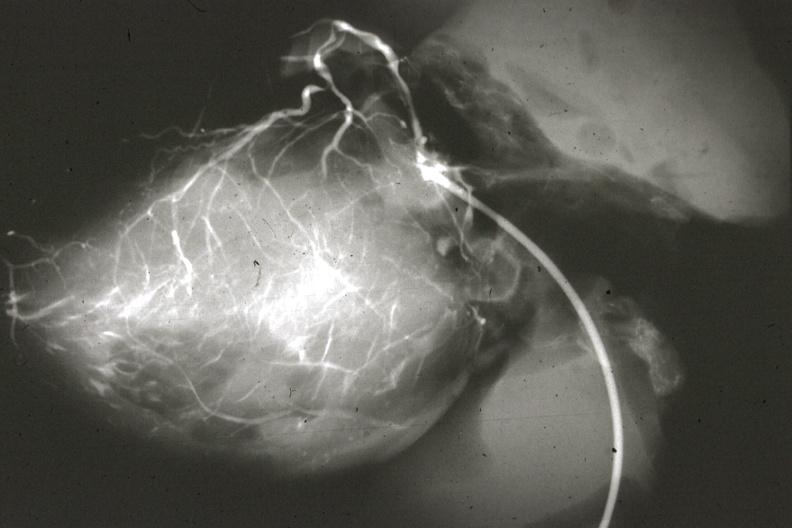s acute lymphocytic leukemia left from pulmonary artery?
Answer the question using a single word or phrase. No 